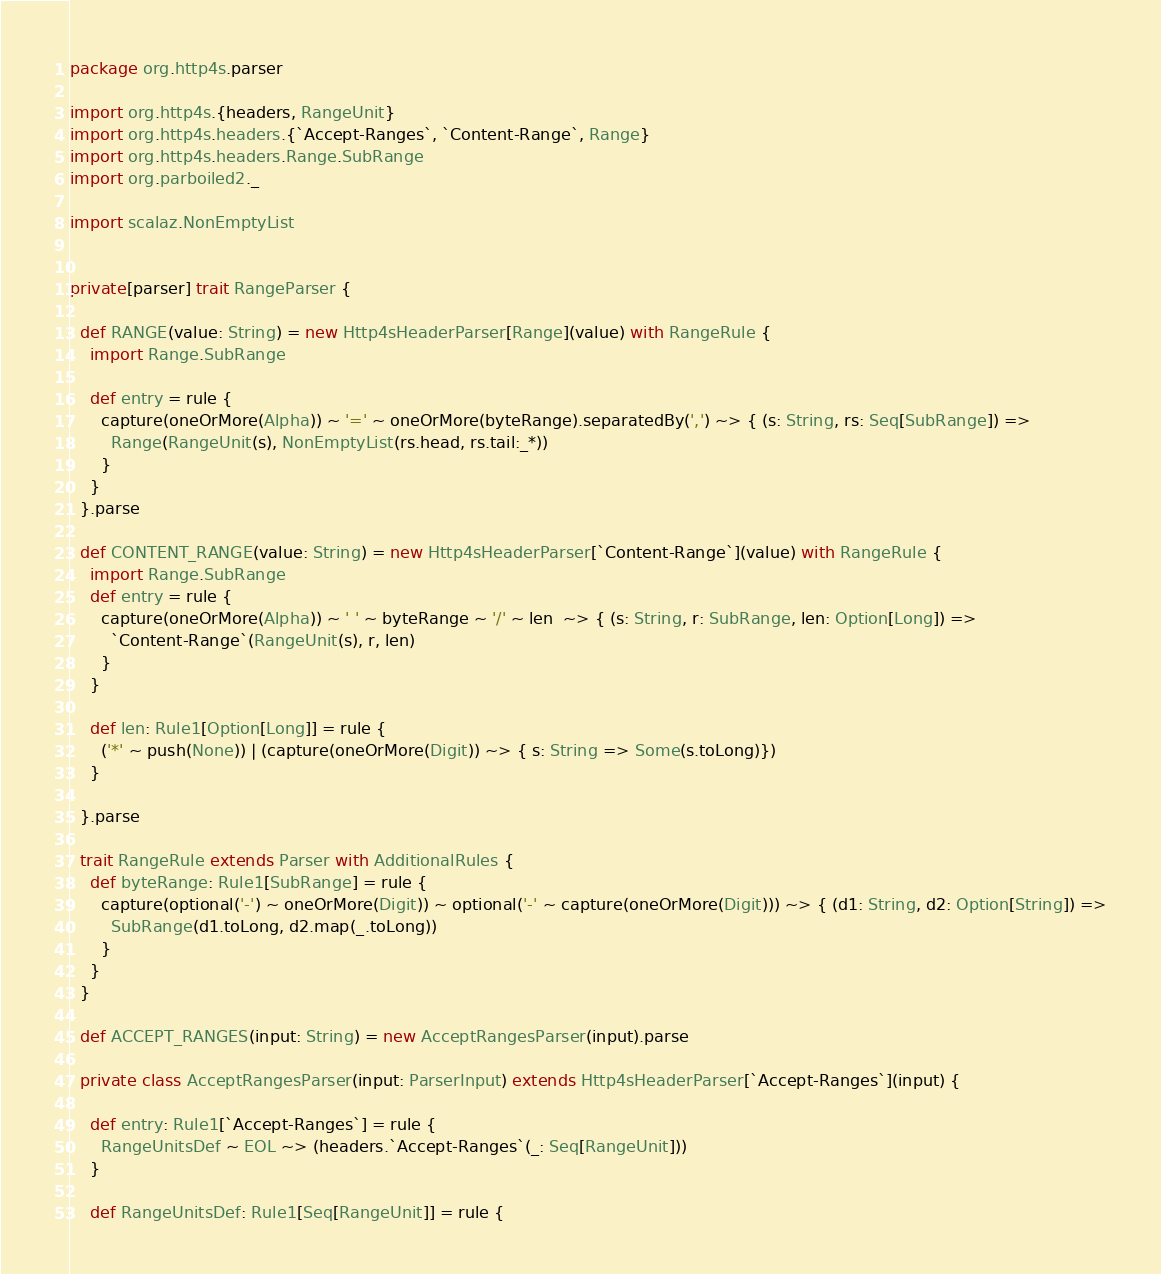Convert code to text. <code><loc_0><loc_0><loc_500><loc_500><_Scala_>package org.http4s.parser

import org.http4s.{headers, RangeUnit}
import org.http4s.headers.{`Accept-Ranges`, `Content-Range`, Range}
import org.http4s.headers.Range.SubRange
import org.parboiled2._

import scalaz.NonEmptyList


private[parser] trait RangeParser {

  def RANGE(value: String) = new Http4sHeaderParser[Range](value) with RangeRule {
    import Range.SubRange

    def entry = rule {
      capture(oneOrMore(Alpha)) ~ '=' ~ oneOrMore(byteRange).separatedBy(',') ~> { (s: String, rs: Seq[SubRange]) =>
        Range(RangeUnit(s), NonEmptyList(rs.head, rs.tail:_*))
      }
    }
  }.parse

  def CONTENT_RANGE(value: String) = new Http4sHeaderParser[`Content-Range`](value) with RangeRule {
    import Range.SubRange
    def entry = rule {
      capture(oneOrMore(Alpha)) ~ ' ' ~ byteRange ~ '/' ~ len  ~> { (s: String, r: SubRange, len: Option[Long]) =>
        `Content-Range`(RangeUnit(s), r, len)
      }
    }

    def len: Rule1[Option[Long]] = rule {
      ('*' ~ push(None)) | (capture(oneOrMore(Digit)) ~> { s: String => Some(s.toLong)})
    }

  }.parse

  trait RangeRule extends Parser with AdditionalRules {
    def byteRange: Rule1[SubRange] = rule {
      capture(optional('-') ~ oneOrMore(Digit)) ~ optional('-' ~ capture(oneOrMore(Digit))) ~> { (d1: String, d2: Option[String]) =>
        SubRange(d1.toLong, d2.map(_.toLong))
      }
    }
  }

  def ACCEPT_RANGES(input: String) = new AcceptRangesParser(input).parse

  private class AcceptRangesParser(input: ParserInput) extends Http4sHeaderParser[`Accept-Ranges`](input) {

    def entry: Rule1[`Accept-Ranges`] = rule {
      RangeUnitsDef ~ EOL ~> (headers.`Accept-Ranges`(_: Seq[RangeUnit]))
    }

    def RangeUnitsDef: Rule1[Seq[RangeUnit]] = rule {</code> 